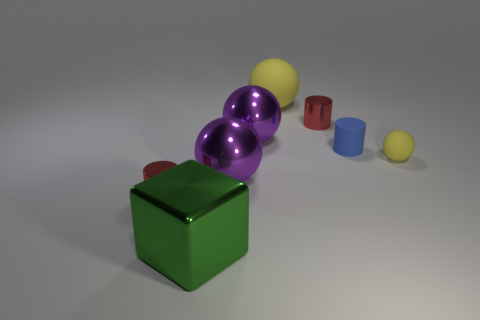Subtract all small yellow rubber balls. How many balls are left? 3 Subtract all gray spheres. Subtract all red cylinders. How many spheres are left? 4 Add 1 blue things. How many objects exist? 9 Subtract all cylinders. How many objects are left? 5 Add 2 large metal cubes. How many large metal cubes are left? 3 Add 2 small red shiny cylinders. How many small red shiny cylinders exist? 4 Subtract 1 blue cylinders. How many objects are left? 7 Subtract all yellow metal cylinders. Subtract all small matte spheres. How many objects are left? 7 